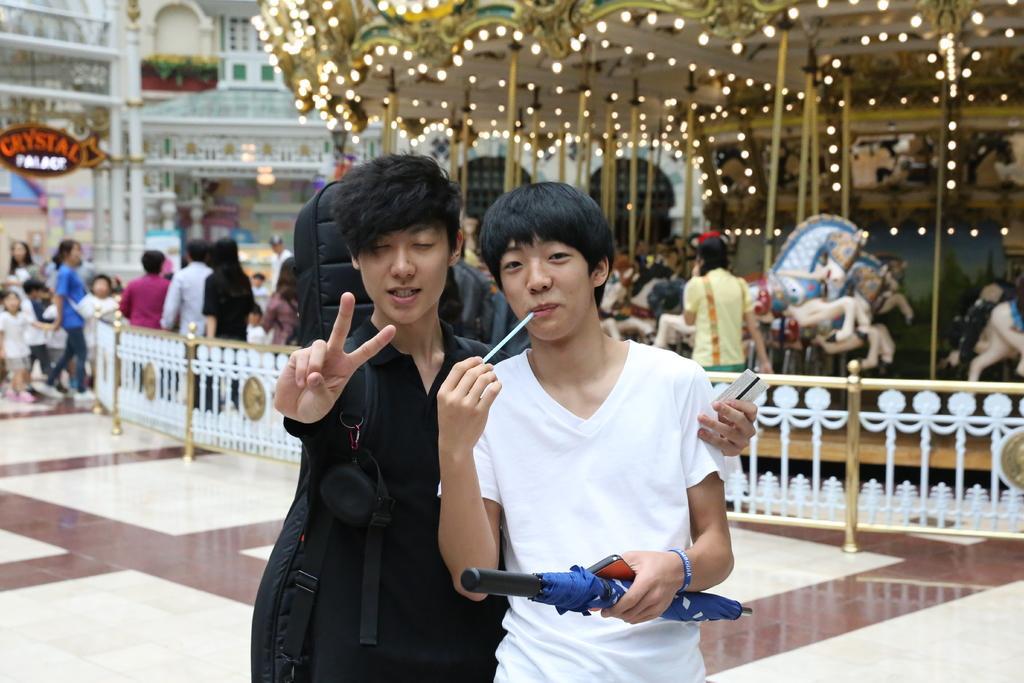Can you describe this image briefly? As we can see in the image there are group of people, lights, buildings, banner, fence and horse statue. 